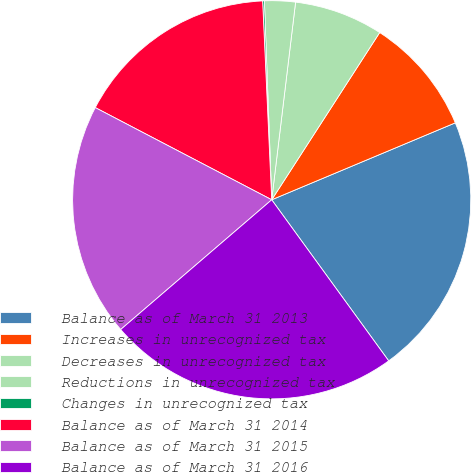Convert chart. <chart><loc_0><loc_0><loc_500><loc_500><pie_chart><fcel>Balance as of March 31 2013<fcel>Increases in unrecognized tax<fcel>Decreases in unrecognized tax<fcel>Reductions in unrecognized tax<fcel>Changes in unrecognized tax<fcel>Balance as of March 31 2014<fcel>Balance as of March 31 2015<fcel>Balance as of March 31 2016<nl><fcel>21.32%<fcel>9.56%<fcel>7.21%<fcel>2.5%<fcel>0.14%<fcel>16.61%<fcel>18.96%<fcel>23.7%<nl></chart> 